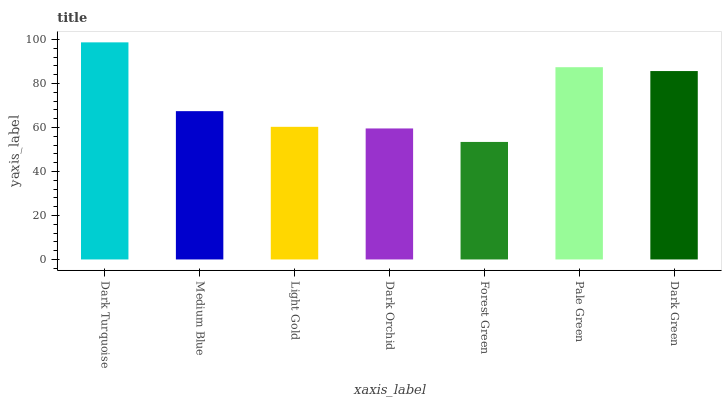Is Forest Green the minimum?
Answer yes or no. Yes. Is Dark Turquoise the maximum?
Answer yes or no. Yes. Is Medium Blue the minimum?
Answer yes or no. No. Is Medium Blue the maximum?
Answer yes or no. No. Is Dark Turquoise greater than Medium Blue?
Answer yes or no. Yes. Is Medium Blue less than Dark Turquoise?
Answer yes or no. Yes. Is Medium Blue greater than Dark Turquoise?
Answer yes or no. No. Is Dark Turquoise less than Medium Blue?
Answer yes or no. No. Is Medium Blue the high median?
Answer yes or no. Yes. Is Medium Blue the low median?
Answer yes or no. Yes. Is Light Gold the high median?
Answer yes or no. No. Is Light Gold the low median?
Answer yes or no. No. 